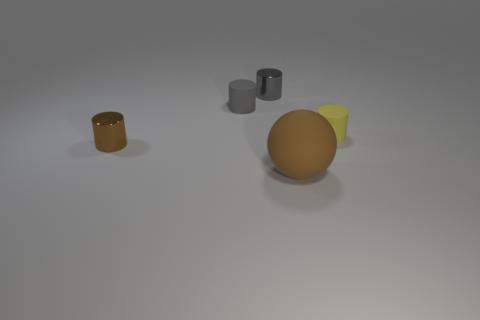What do the colors and materials of the objects suggest about the setting or atmosphere of the image? The muted colors and matte finish of the objects, along with the soft lighting and shadowing, suggest a calm, subdued setting. The choice of colors and materials might indicate a preference for simplicity and minimalism, or they could be part of a controlled setting such as an artist's studio or a classroom for studying forms and shadows. The absence of vivid colors and reflective surfaces creates an atmosphere that is understated and focused on the shapes and composition of the objects. 